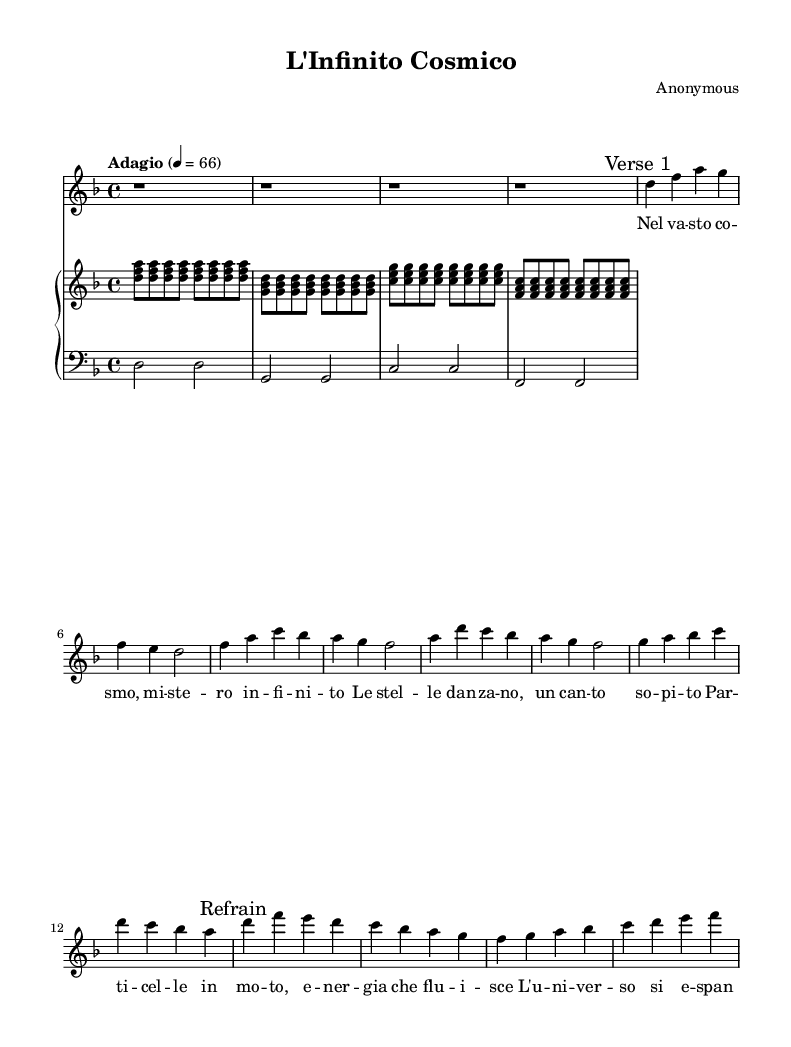What is the key signature of this music? The key signature is defined at the beginning of the sheet music, where we see a "d" and no flats or sharps. This indicates that the piece is in the key of D minor.
Answer: D minor What is the time signature of this piece? The time signature is indicated early in the sheet music, where it is noted as 4/4. This means there are four beats in each measure and the quarter note gets one beat.
Answer: 4/4 What is the tempo marking for this aria? The tempo marking, which is usually displayed at the beginning of the sheet music, states "Adagio," with a metronome marking of 4 = 66. This indicates a slow pace.
Answer: Adagio How many measures are in the first verse? By counting the distinct musical phrases, we identify that the first verse consists of 8 measures, as the notation in that section corresponds to 8 individual rhythmic groups.
Answer: 8 What musical elements are present in the refrain? The refrain section includes melodic phrases, harmony from the piano accompaniment, and lyrics that express a thematic element, focusing on the mysteries of the universe, specifically highlighted by the repeated musical figures and textual emphasis.
Answer: Melodic phrases and harmony What is the central theme explored in the lyrics of this aria? The lyrics suggest a contemplation of the cosmos and its mysteries, with phrases like "infinito" (infinite) and references to celestial energy, emphasizing a philosophical reflection on existence and the universe.
Answer: The mysteries of the universe What is the structure of the opera piece? The structure is delineated as an introduction followed by verses and refrains, indicating a traditional operatic format where themes are developed and revisited, with a primary focus on reflecting the cosmic narrative.
Answer: Introduction, verses, and refrains 